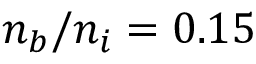<formula> <loc_0><loc_0><loc_500><loc_500>n _ { b } / n _ { i } = 0 . 1 5</formula> 